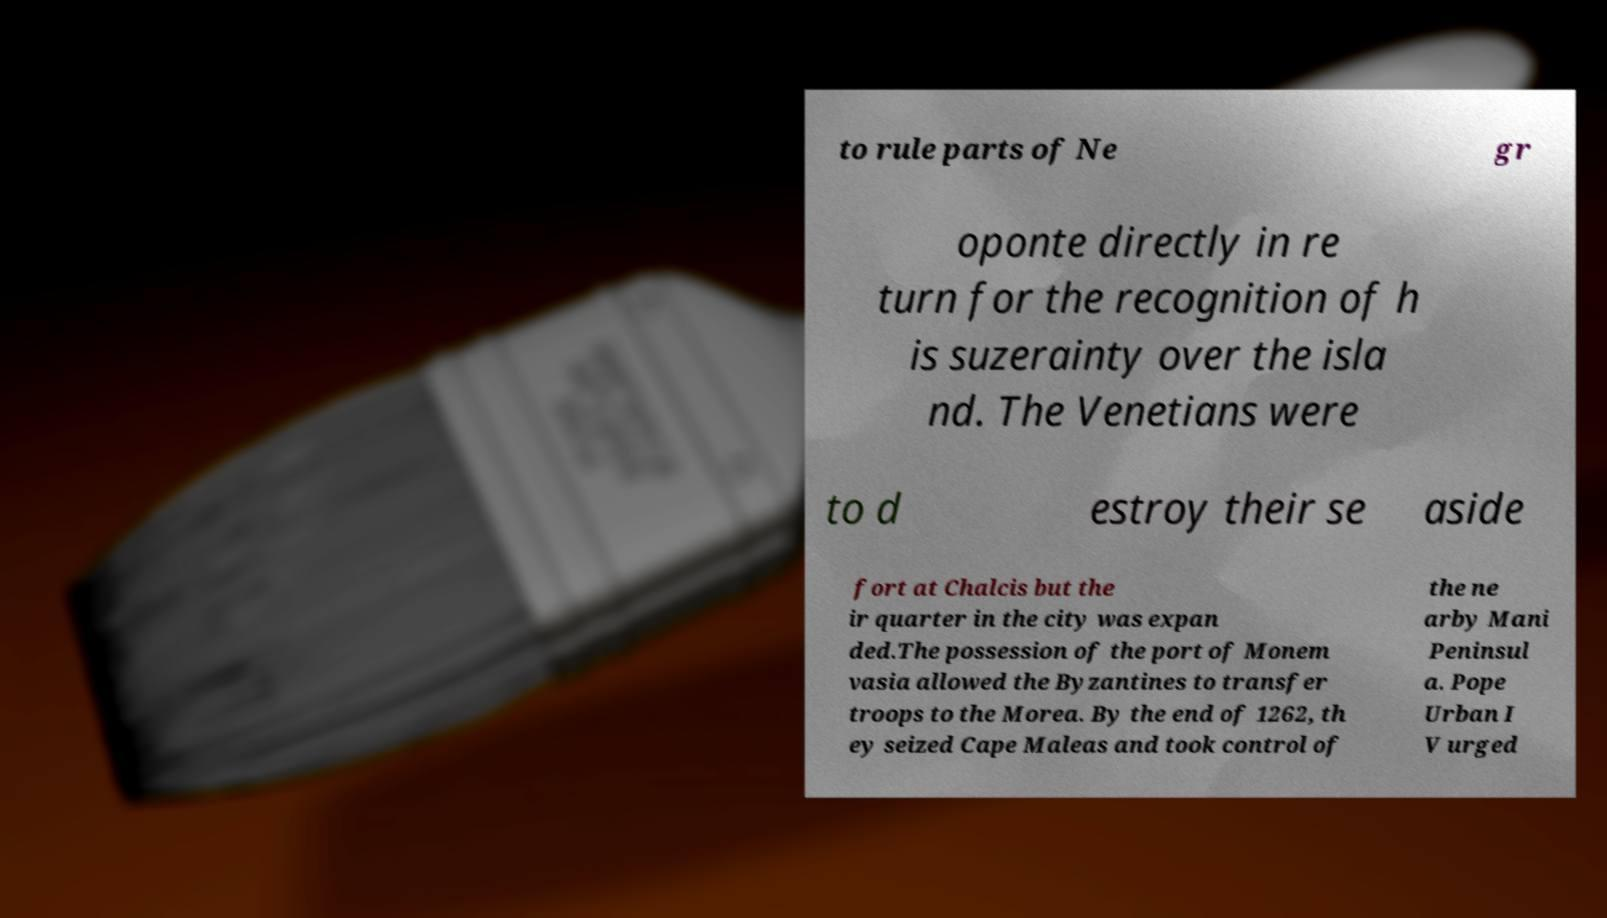Can you read and provide the text displayed in the image?This photo seems to have some interesting text. Can you extract and type it out for me? to rule parts of Ne gr oponte directly in re turn for the recognition of h is suzerainty over the isla nd. The Venetians were to d estroy their se aside fort at Chalcis but the ir quarter in the city was expan ded.The possession of the port of Monem vasia allowed the Byzantines to transfer troops to the Morea. By the end of 1262, th ey seized Cape Maleas and took control of the ne arby Mani Peninsul a. Pope Urban I V urged 